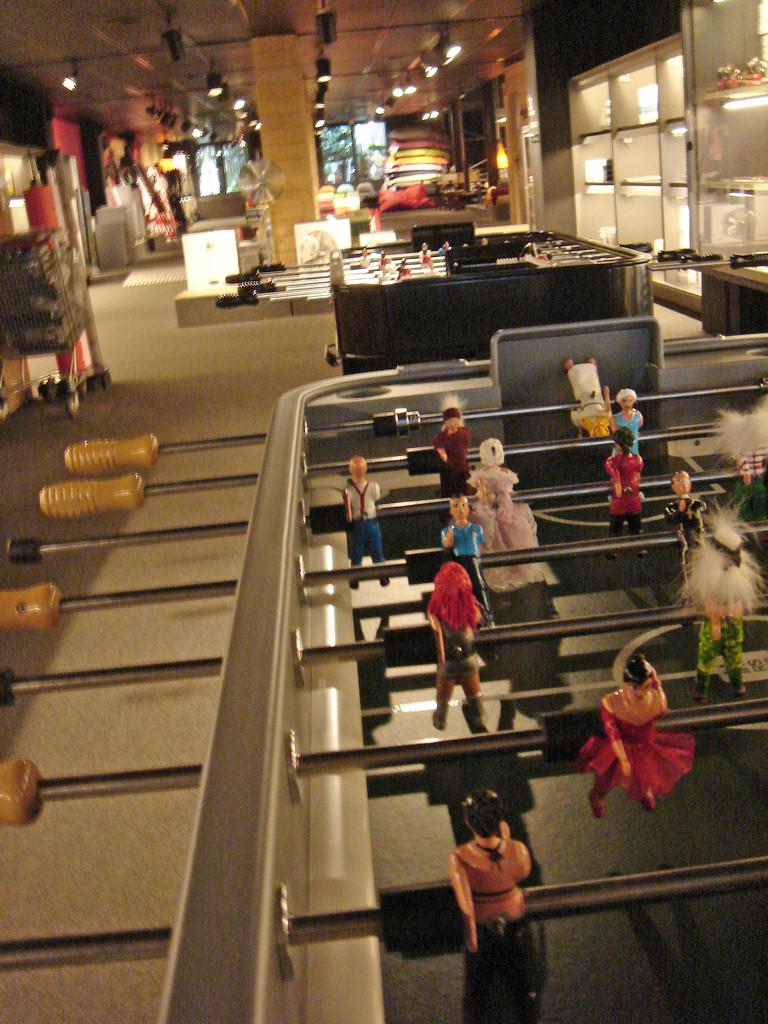What type of game boards are featured in the image? There are mini soccer game boards in the image. What else can be seen in the image besides the game boards? There are lights and some other objects in the image. What song is being played by the ducks in the image? There are no ducks or music present in the image, so it is not possible to determine what song might be played. 